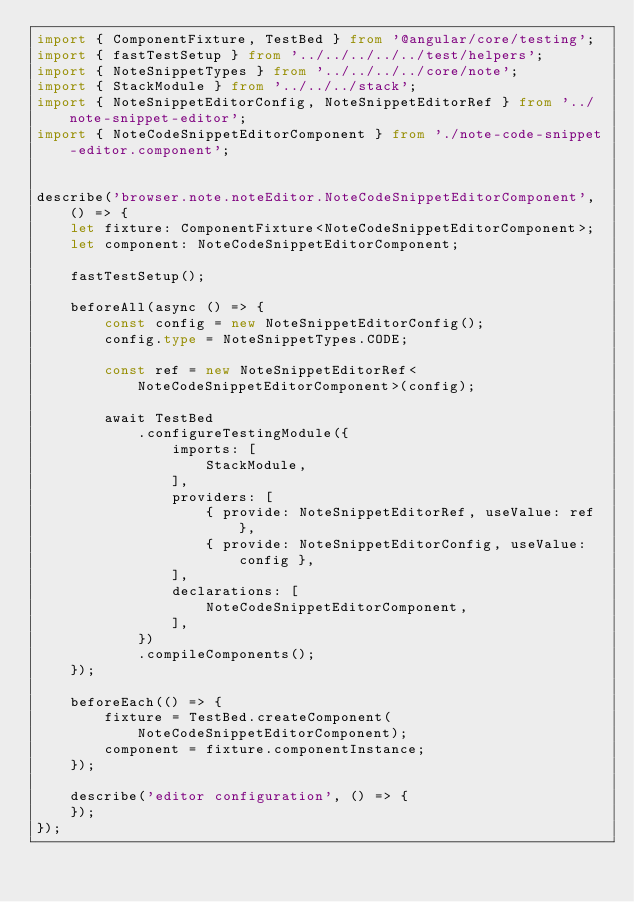Convert code to text. <code><loc_0><loc_0><loc_500><loc_500><_TypeScript_>import { ComponentFixture, TestBed } from '@angular/core/testing';
import { fastTestSetup } from '../../../../../test/helpers';
import { NoteSnippetTypes } from '../../../../core/note';
import { StackModule } from '../../../stack';
import { NoteSnippetEditorConfig, NoteSnippetEditorRef } from '../note-snippet-editor';
import { NoteCodeSnippetEditorComponent } from './note-code-snippet-editor.component';


describe('browser.note.noteEditor.NoteCodeSnippetEditorComponent', () => {
    let fixture: ComponentFixture<NoteCodeSnippetEditorComponent>;
    let component: NoteCodeSnippetEditorComponent;

    fastTestSetup();

    beforeAll(async () => {
        const config = new NoteSnippetEditorConfig();
        config.type = NoteSnippetTypes.CODE;

        const ref = new NoteSnippetEditorRef<NoteCodeSnippetEditorComponent>(config);

        await TestBed
            .configureTestingModule({
                imports: [
                    StackModule,
                ],
                providers: [
                    { provide: NoteSnippetEditorRef, useValue: ref },
                    { provide: NoteSnippetEditorConfig, useValue: config },
                ],
                declarations: [
                    NoteCodeSnippetEditorComponent,
                ],
            })
            .compileComponents();
    });

    beforeEach(() => {
        fixture = TestBed.createComponent(NoteCodeSnippetEditorComponent);
        component = fixture.componentInstance;
    });

    describe('editor configuration', () => {
    });
});
</code> 